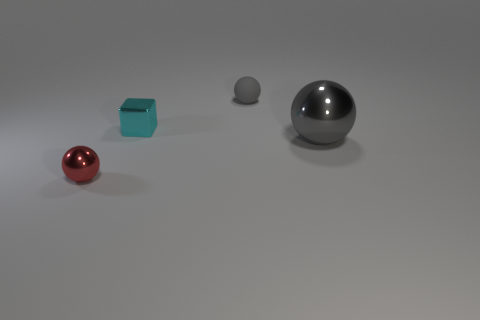There is a sphere that is to the right of the tiny gray ball; what material is it?
Make the answer very short. Metal. What number of red metal objects have the same shape as the small rubber object?
Offer a very short reply. 1. What material is the small thing that is behind the gray shiny thing and on the left side of the gray rubber thing?
Your response must be concise. Metal. Is the tiny red object made of the same material as the small gray ball?
Give a very brief answer. No. What number of shiny balls are there?
Make the answer very short. 2. There is a object that is left of the tiny metallic object that is behind the metal ball that is left of the tiny rubber thing; what color is it?
Ensure brevity in your answer.  Red. Is the color of the big ball the same as the matte sphere?
Your response must be concise. Yes. What number of balls are to the left of the big object and to the right of the red thing?
Give a very brief answer. 1. How many metal objects are either big gray things or small balls?
Your answer should be compact. 2. What material is the tiny sphere right of the metal ball left of the matte thing?
Your response must be concise. Rubber. 